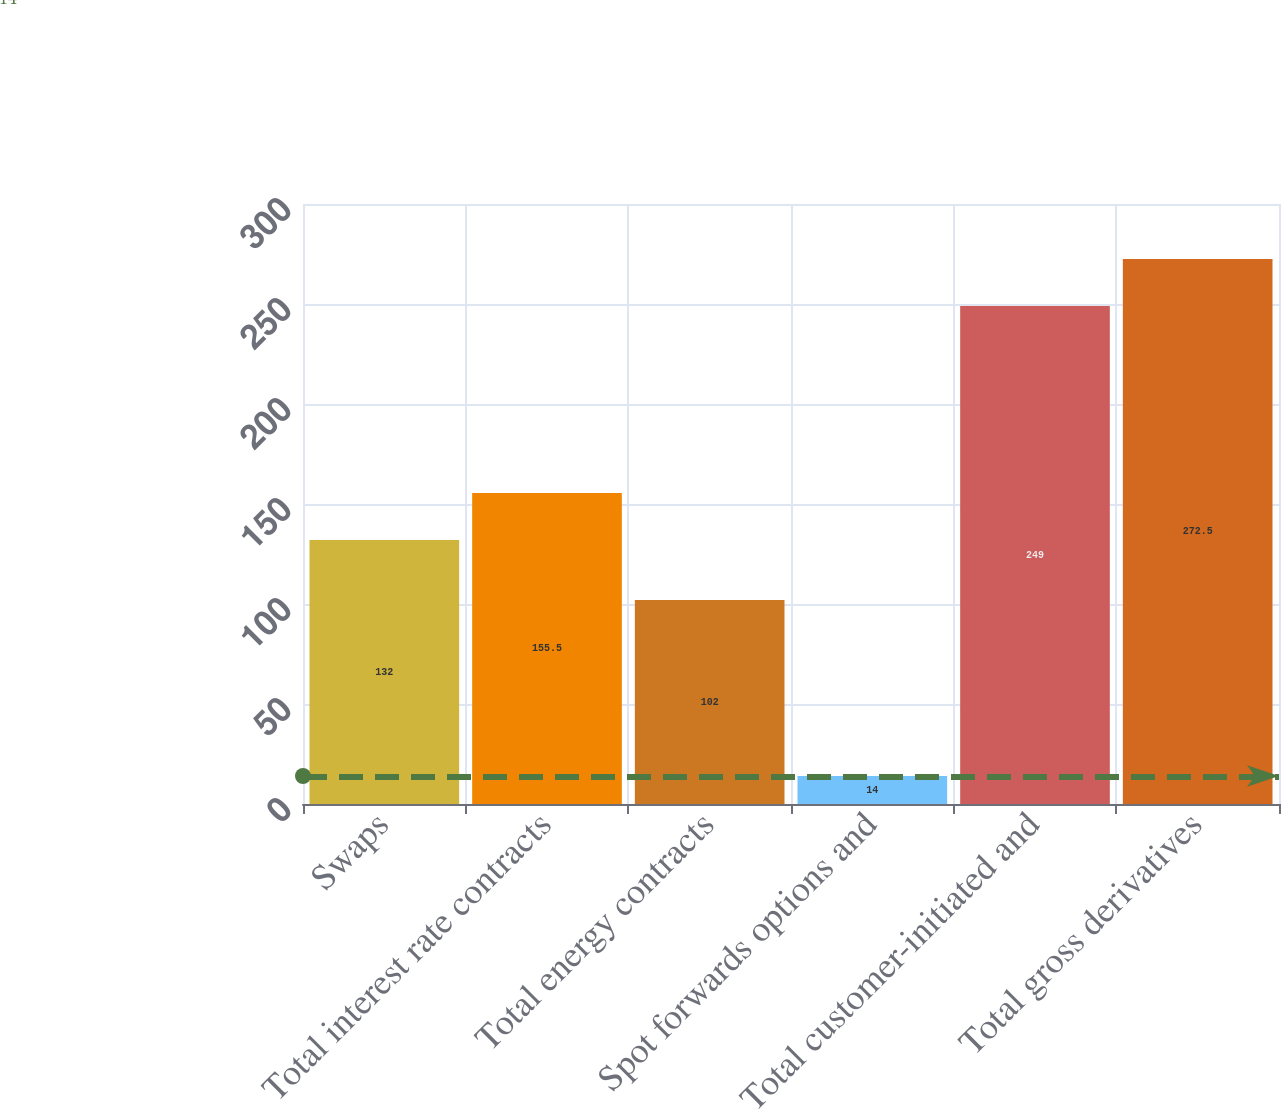Convert chart. <chart><loc_0><loc_0><loc_500><loc_500><bar_chart><fcel>Swaps<fcel>Total interest rate contracts<fcel>Total energy contracts<fcel>Spot forwards options and<fcel>Total customer-initiated and<fcel>Total gross derivatives<nl><fcel>132<fcel>155.5<fcel>102<fcel>14<fcel>249<fcel>272.5<nl></chart> 